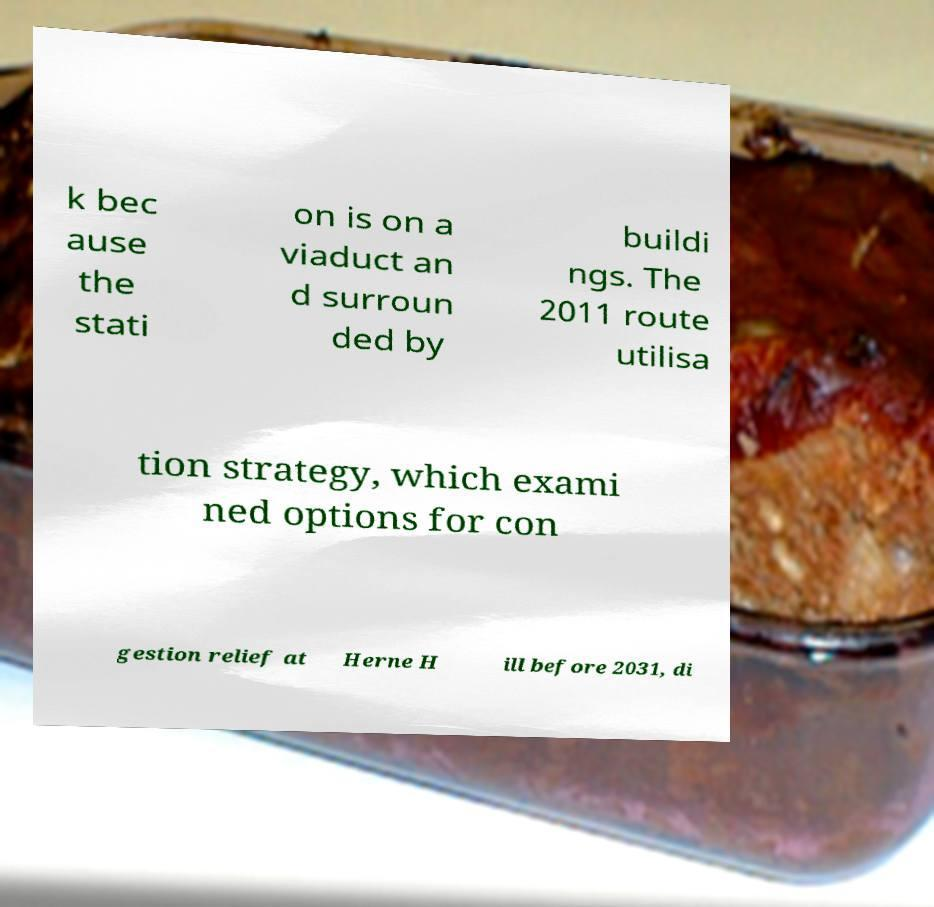Can you read and provide the text displayed in the image?This photo seems to have some interesting text. Can you extract and type it out for me? k bec ause the stati on is on a viaduct an d surroun ded by buildi ngs. The 2011 route utilisa tion strategy, which exami ned options for con gestion relief at Herne H ill before 2031, di 